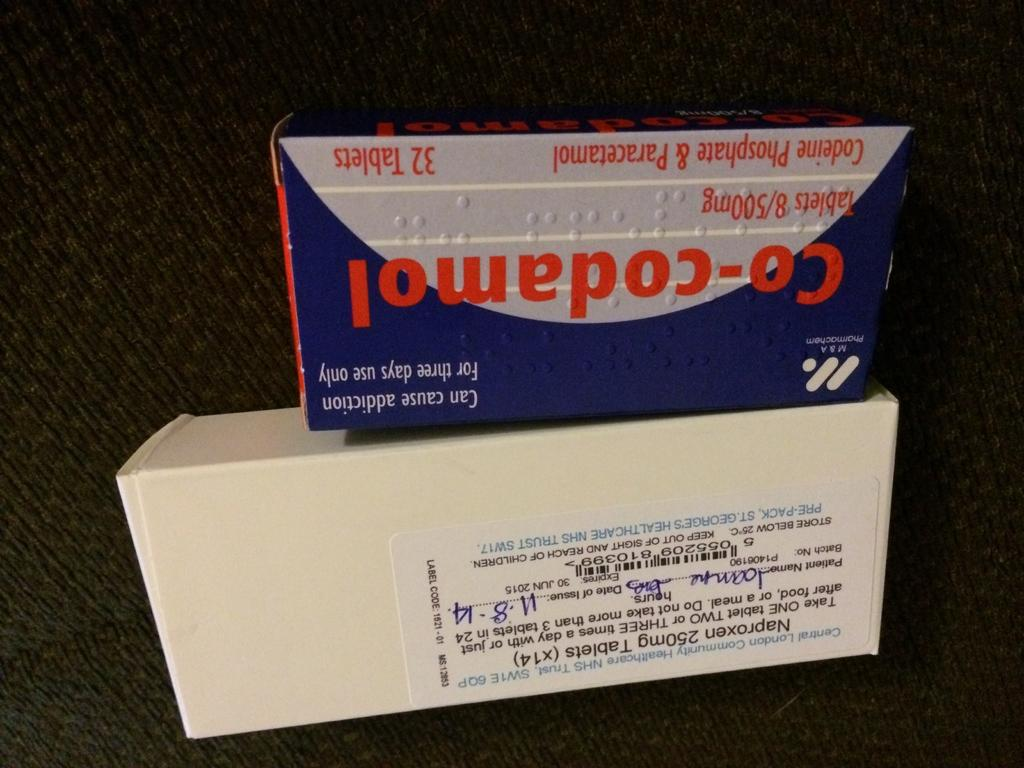<image>
Present a compact description of the photo's key features. A box with an addiction warning is on top of another box. 